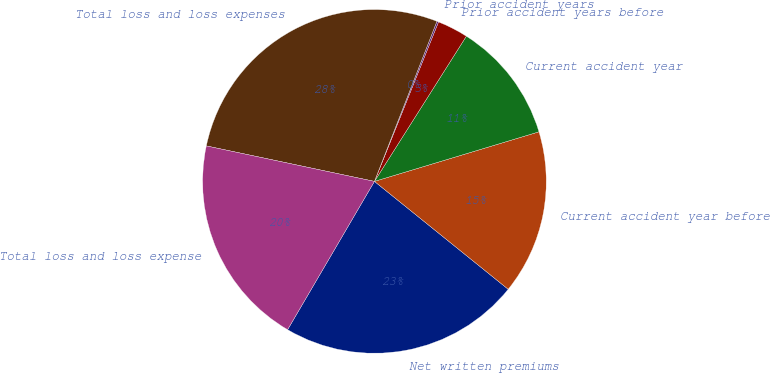<chart> <loc_0><loc_0><loc_500><loc_500><pie_chart><fcel>Net written premiums<fcel>Current accident year before<fcel>Current accident year<fcel>Prior accident years before<fcel>Prior accident years<fcel>Total loss and loss expenses<fcel>Total loss and loss expense<nl><fcel>22.63%<fcel>15.46%<fcel>11.36%<fcel>2.9%<fcel>0.16%<fcel>27.61%<fcel>19.88%<nl></chart> 